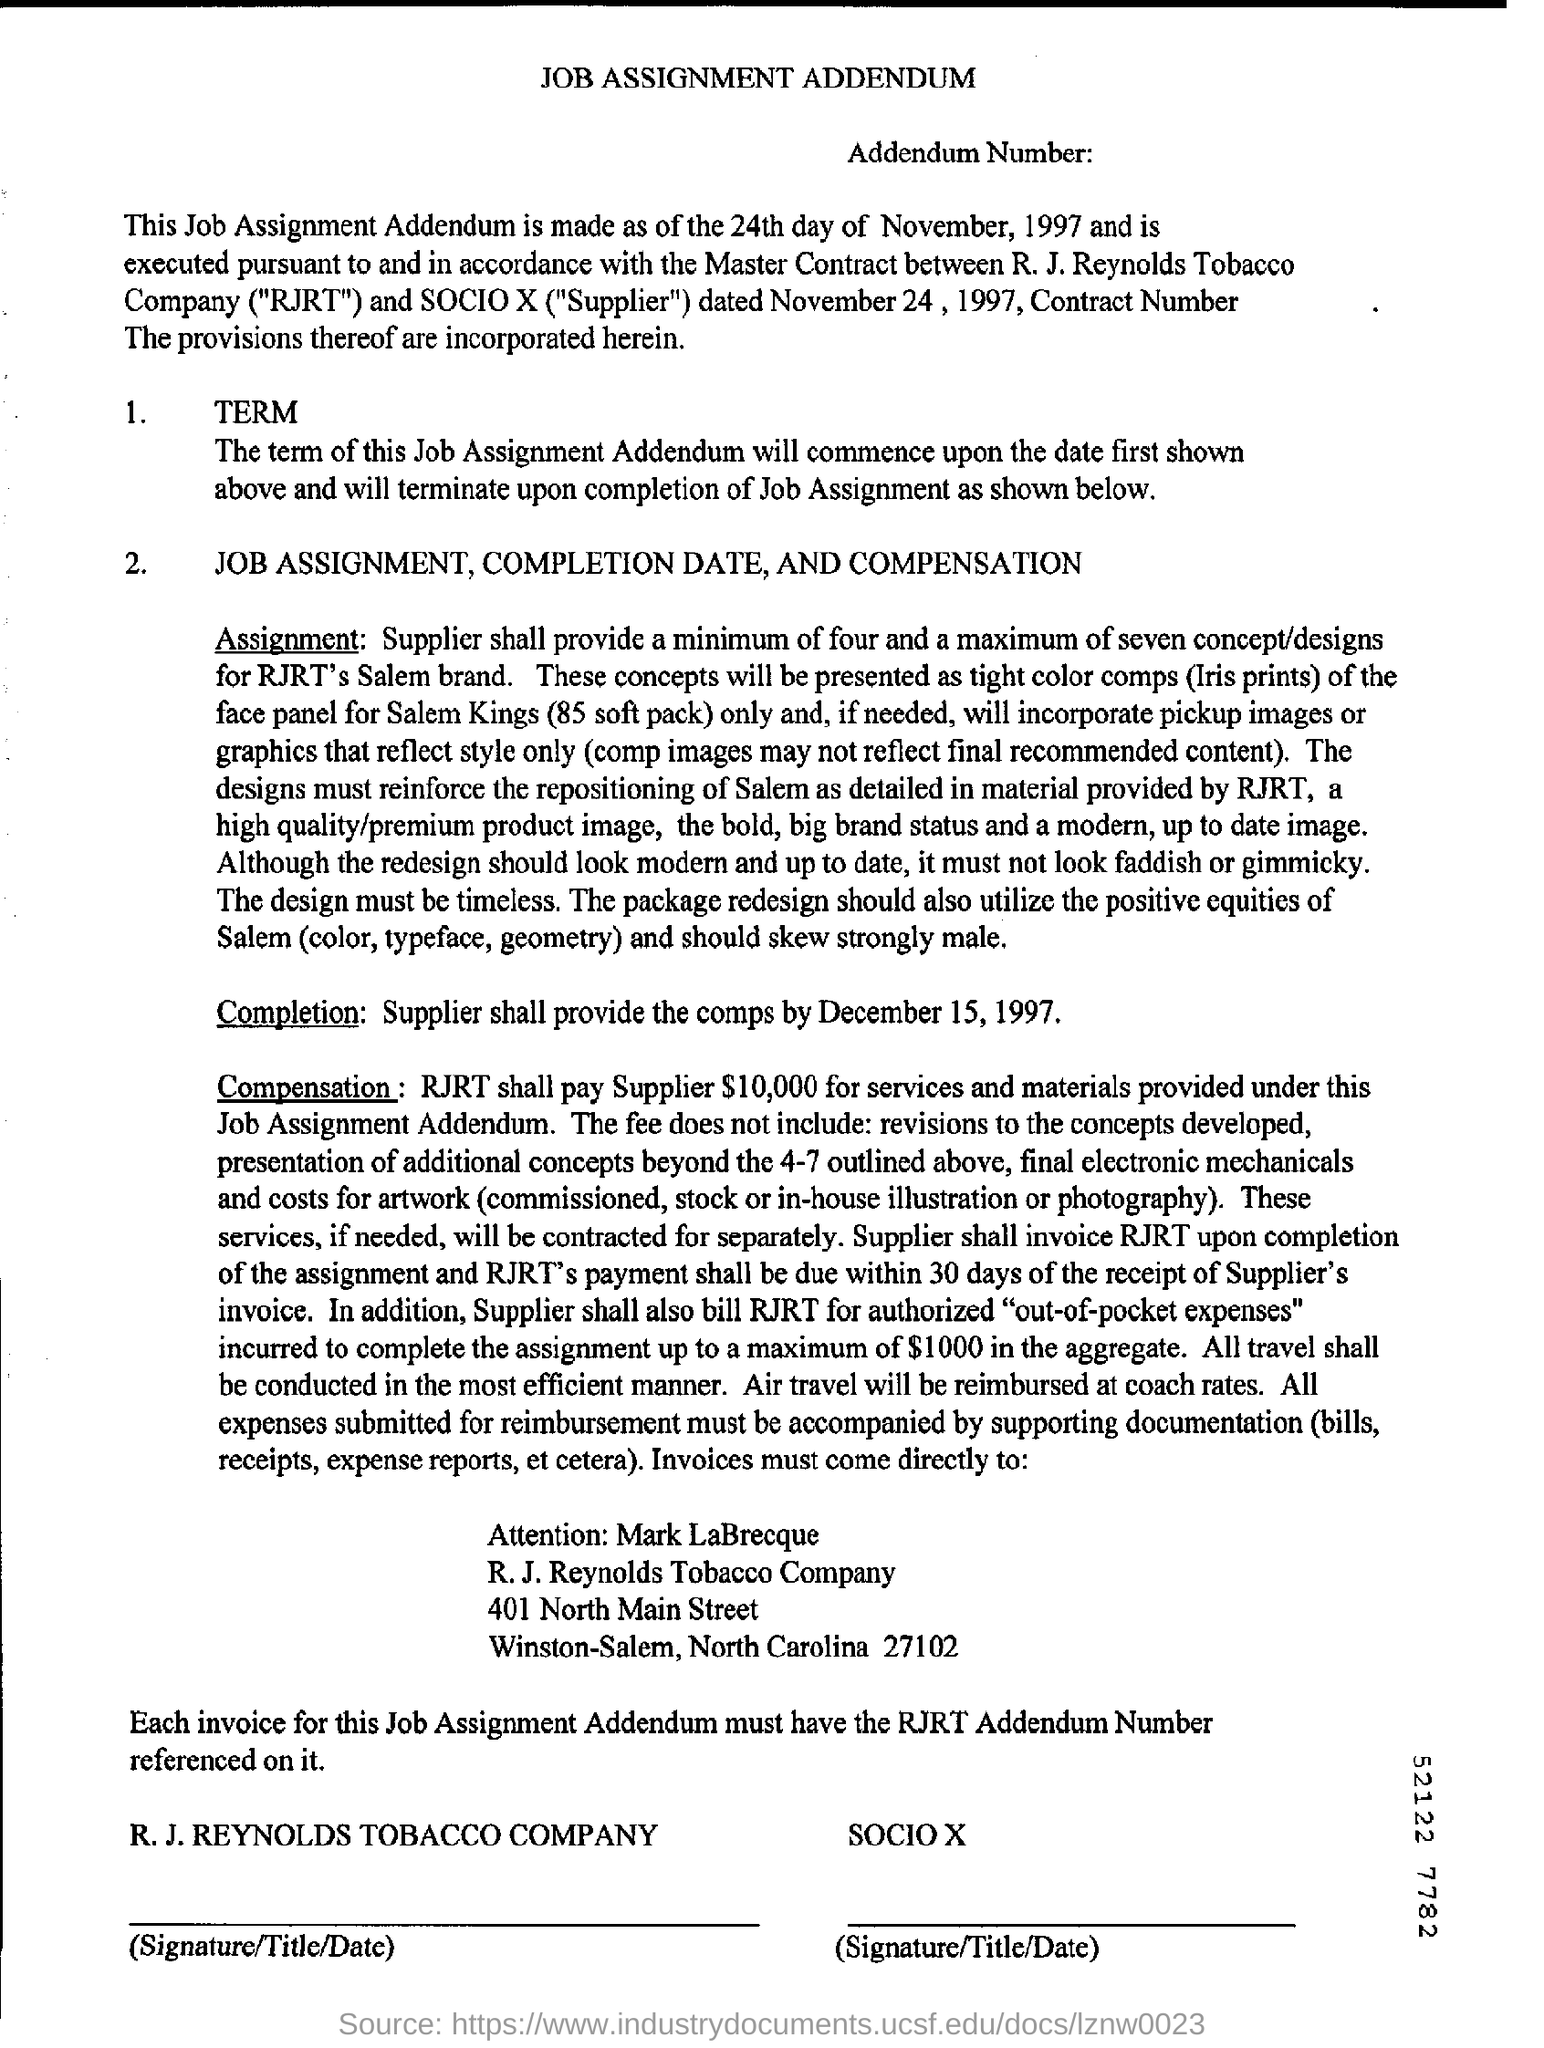What is the heading at top of the page ?
Your answer should be very brief. Job Assignment Addendum. What does rjrt stands for ?
Offer a very short reply. R.J. Reynolds Tobacco Company. 